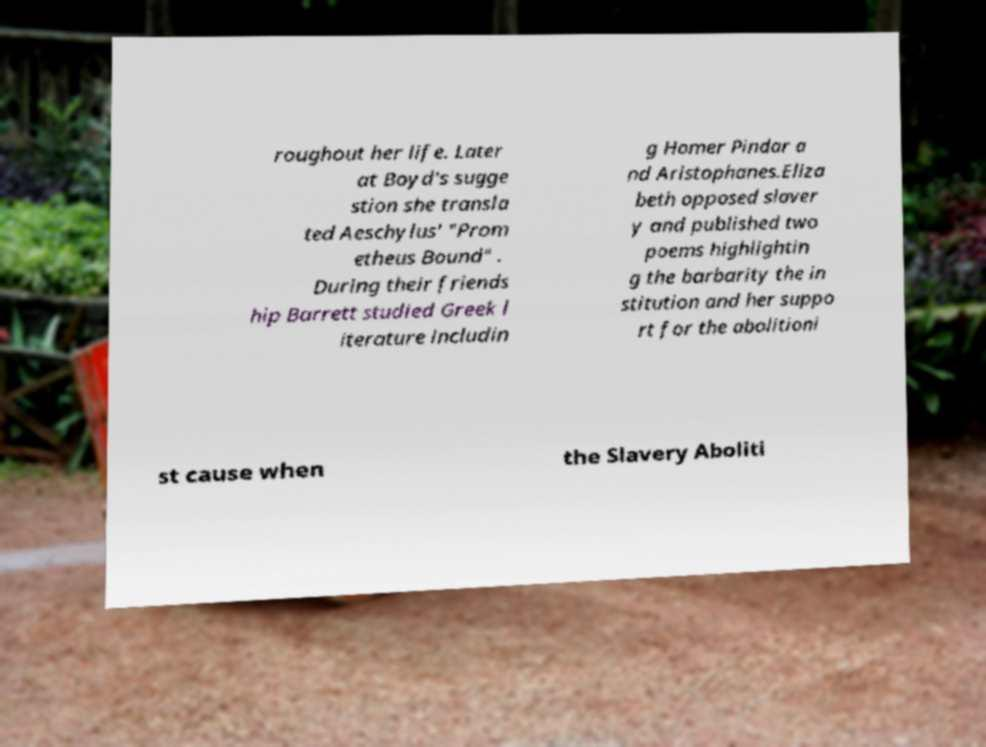For documentation purposes, I need the text within this image transcribed. Could you provide that? roughout her life. Later at Boyd's sugge stion she transla ted Aeschylus' "Prom etheus Bound" . During their friends hip Barrett studied Greek l iterature includin g Homer Pindar a nd Aristophanes.Eliza beth opposed slaver y and published two poems highlightin g the barbarity the in stitution and her suppo rt for the abolitioni st cause when the Slavery Aboliti 